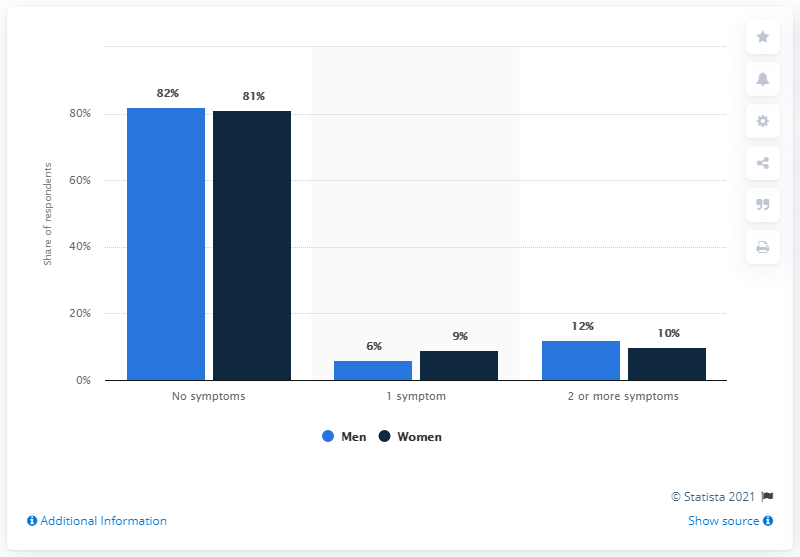Draw attention to some important aspects in this diagram. According to the provided data, 18% of men reported having at least one symptom. The most common feedback in the chart is that individuals report no symptoms. 